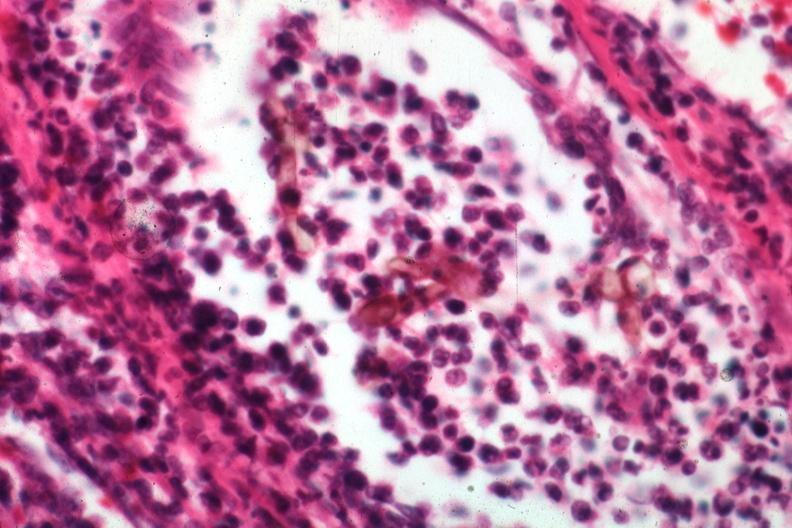s this section showing liver with tumor mass in hilar area tumor present?
Answer the question using a single word or phrase. No 